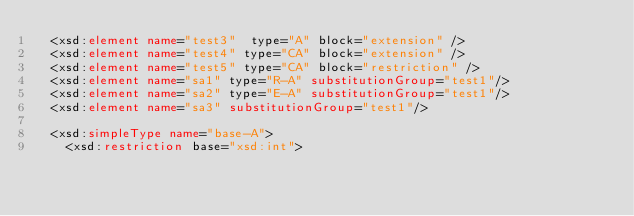<code> <loc_0><loc_0><loc_500><loc_500><_XML_>	<xsd:element name="test3"  type="A" block="extension" />
	<xsd:element name="test4" type="CA" block="extension" />
	<xsd:element name="test5" type="CA" block="restriction" />
	<xsd:element name="sa1" type="R-A" substitutionGroup="test1"/>
	<xsd:element name="sa2" type="E-A" substitutionGroup="test1"/>
	<xsd:element name="sa3" substitutionGroup="test1"/>

	<xsd:simpleType name="base-A">
		<xsd:restriction base="xsd:int"></code> 